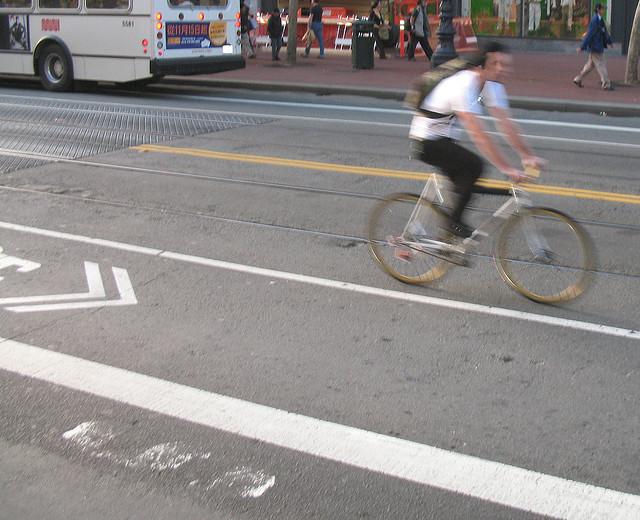Is the bike moving?
Be succinct. Yes. Where is the bicycle?
Be succinct. Street. Is this in the country or the city?
Give a very brief answer. City. 